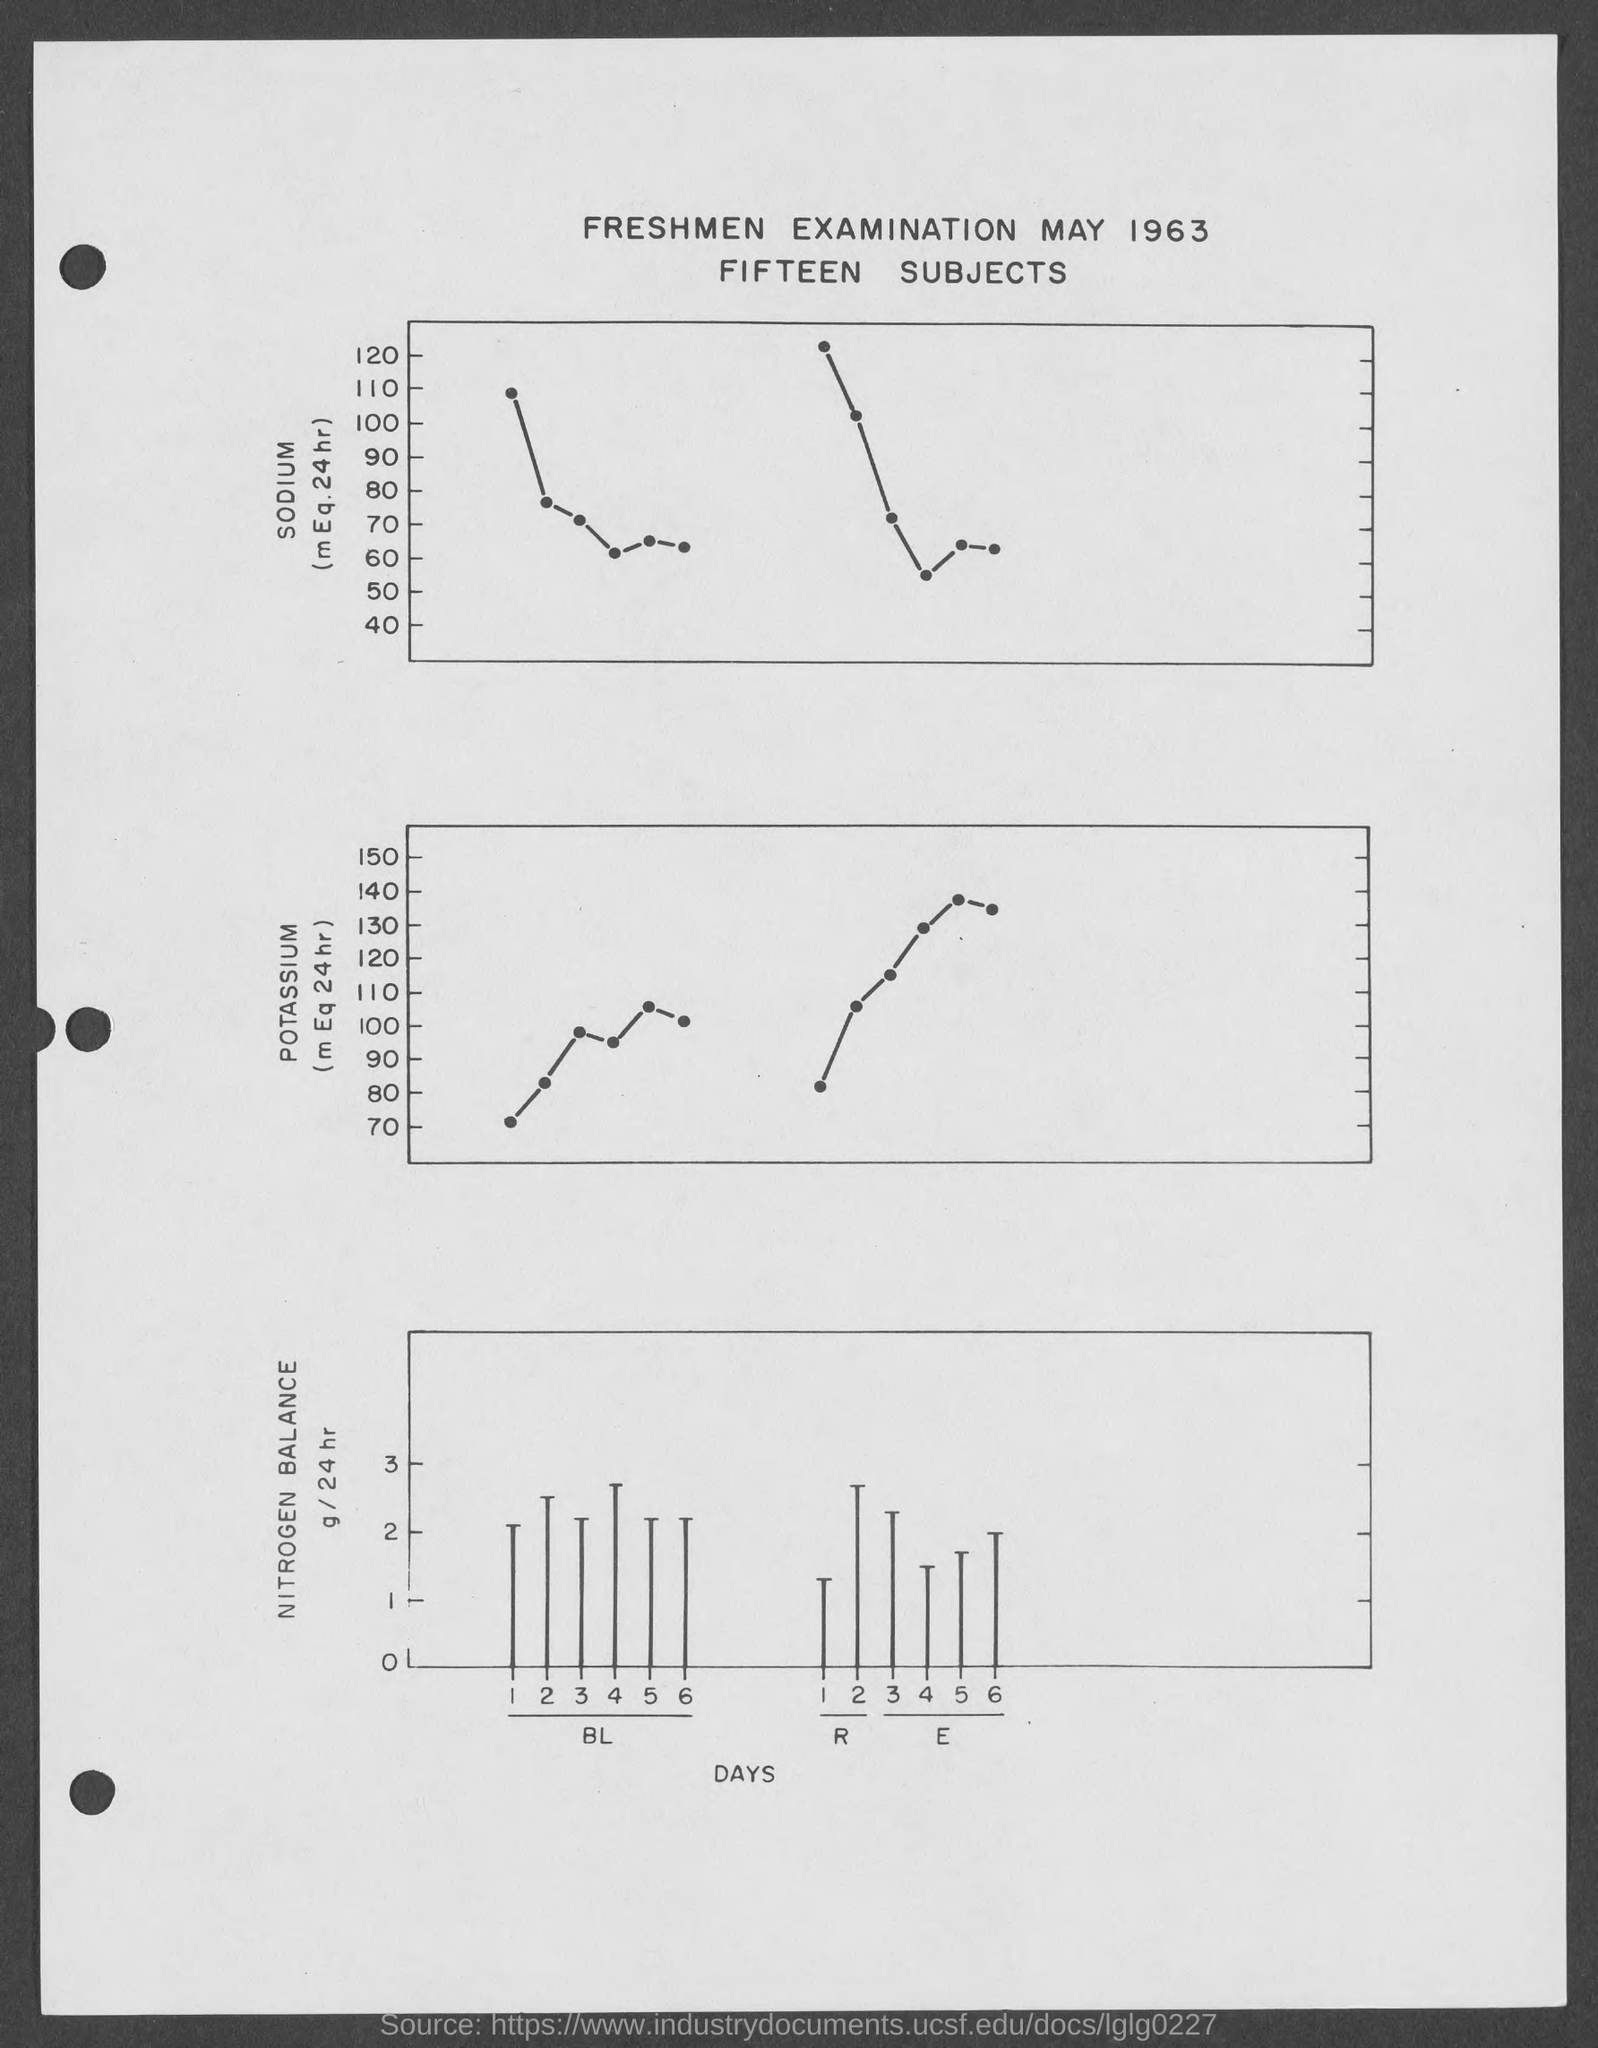What is the month mentioned in the given form ?
Keep it short and to the point. May. What is the year mentioned in the given form ?
Offer a terse response. 1963. How many subjects are mentioned in the given page ?
Your response must be concise. Fifteen. 